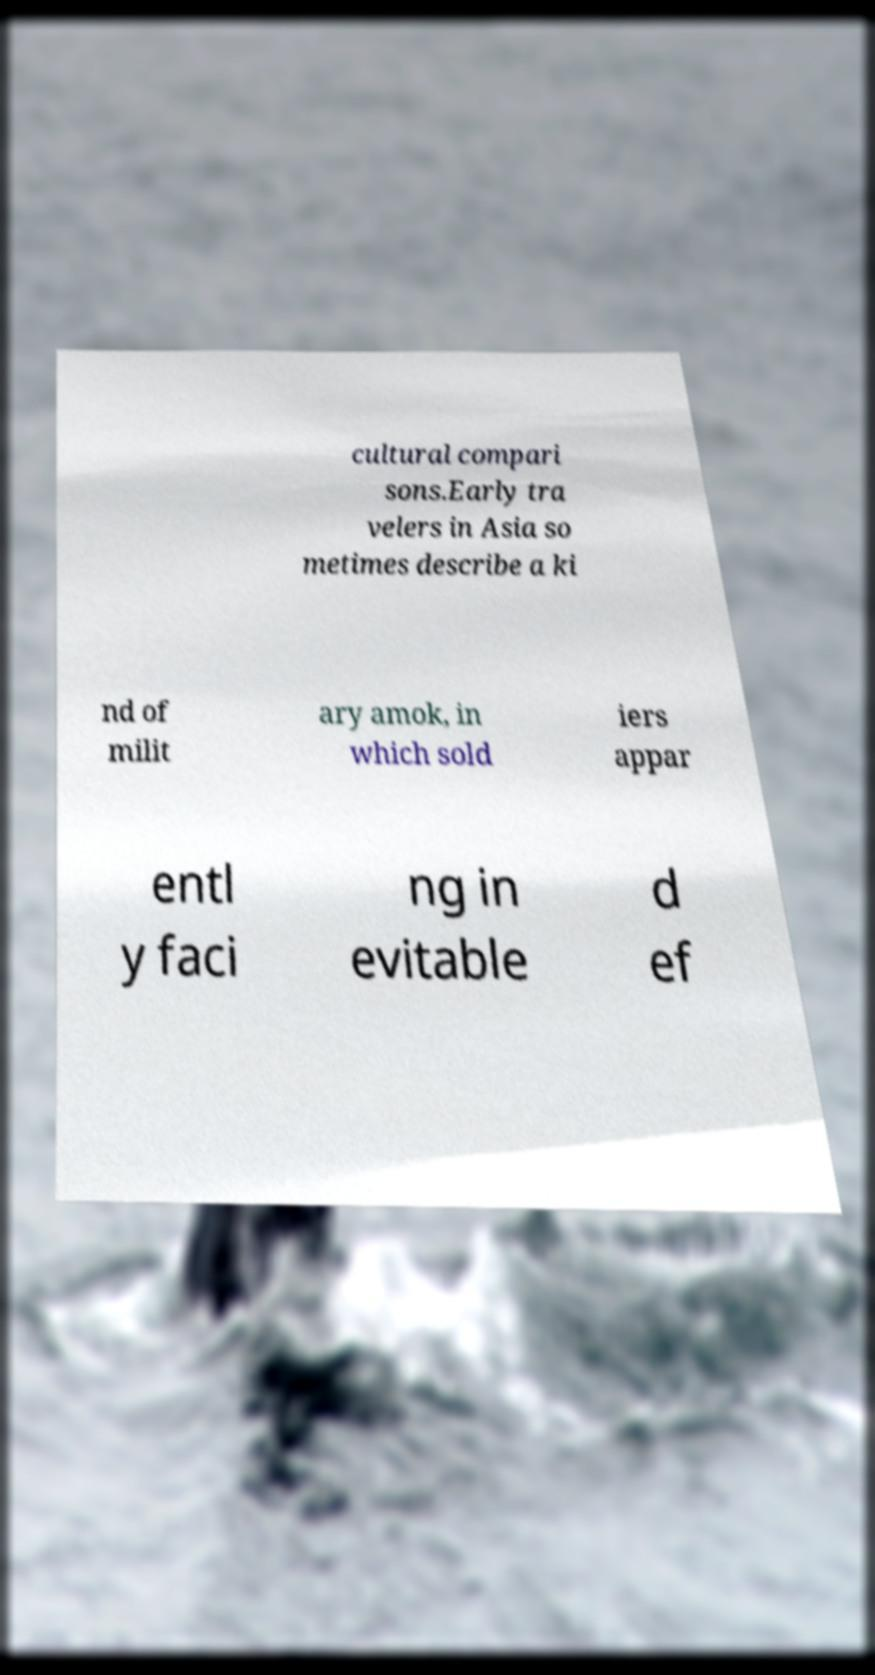Please identify and transcribe the text found in this image. cultural compari sons.Early tra velers in Asia so metimes describe a ki nd of milit ary amok, in which sold iers appar entl y faci ng in evitable d ef 